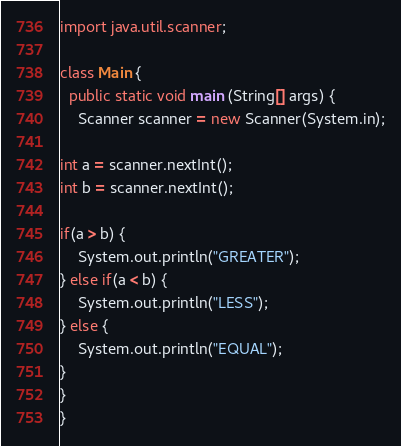Convert code to text. <code><loc_0><loc_0><loc_500><loc_500><_Java_>import java.util.scanner;
 
class Main {
  public static void main (String[] args) {
    Scanner scanner = new Scanner(System.in);
 
int a = scanner.nextInt();
int b = scanner.nextInt();
 
if(a > b) {
    System.out.println("GREATER");
} else if(a < b) {
    System.out.println("LESS");
} else {
    System.out.println("EQUAL");
}
}
}</code> 